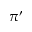Convert formula to latex. <formula><loc_0><loc_0><loc_500><loc_500>\pi ^ { \prime }</formula> 